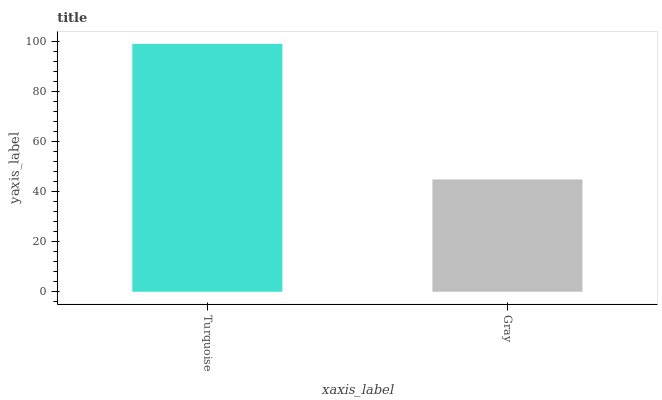Is Gray the minimum?
Answer yes or no. Yes. Is Turquoise the maximum?
Answer yes or no. Yes. Is Gray the maximum?
Answer yes or no. No. Is Turquoise greater than Gray?
Answer yes or no. Yes. Is Gray less than Turquoise?
Answer yes or no. Yes. Is Gray greater than Turquoise?
Answer yes or no. No. Is Turquoise less than Gray?
Answer yes or no. No. Is Turquoise the high median?
Answer yes or no. Yes. Is Gray the low median?
Answer yes or no. Yes. Is Gray the high median?
Answer yes or no. No. Is Turquoise the low median?
Answer yes or no. No. 